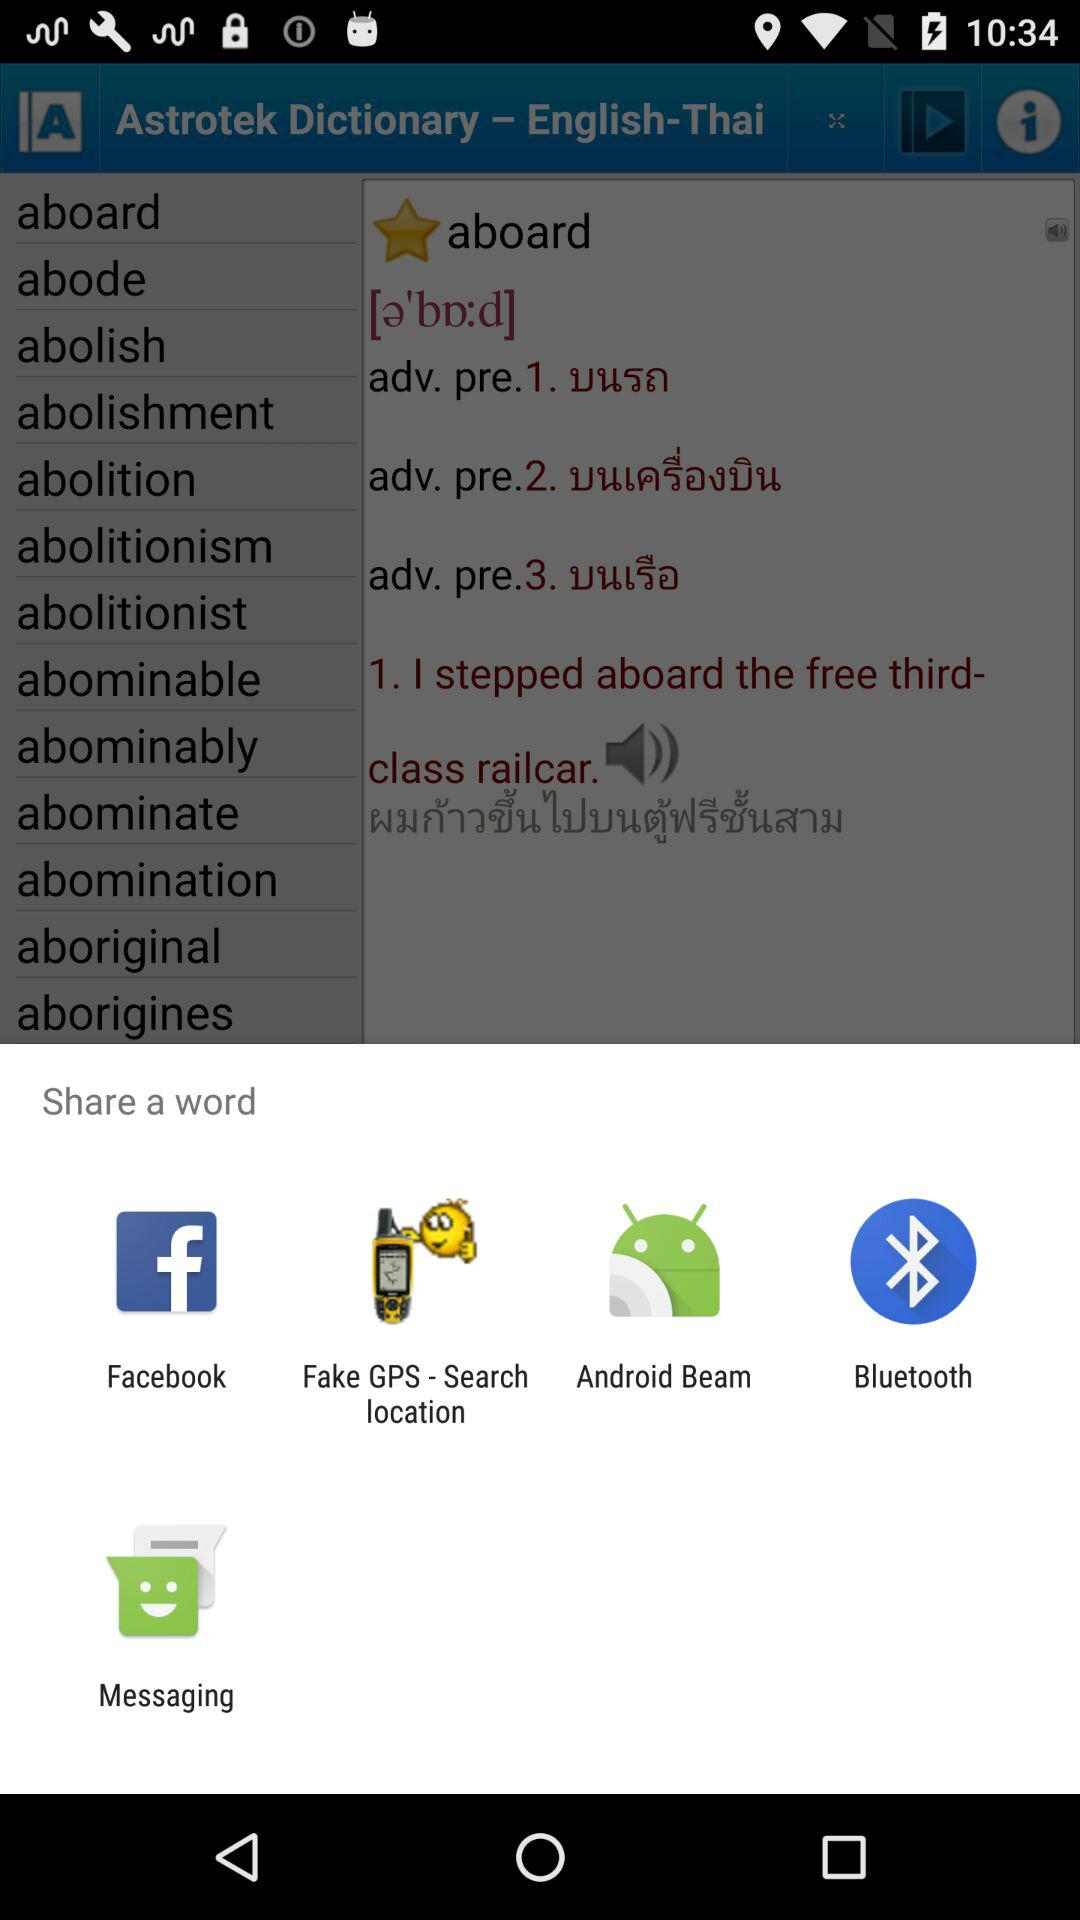Through which app can I share? You can share through "Facebook", "Fake GPS - Search location", "Android Beam", "Bluetooth" and "Messaging". 